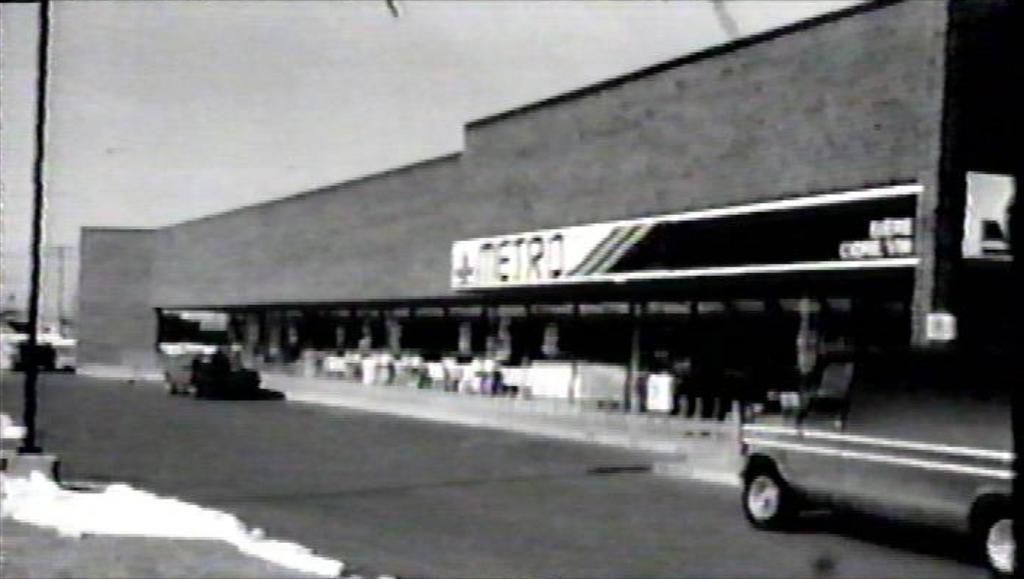What is the color scheme of the image? The image is black and white. How would you describe the clarity of the image? The image is blurred. What is the main subject in the center of the image? There is a building in the center of the image. What can be seen in the foreground of the image? There are cars and a pole in the foreground of the image. Where is the pole located in relation to the road? The pole is on the road. How many snakes are slithering around the pole in the image? There are no snakes present in the image; it features a building, cars, and a pole on the road. What type of shop can be seen near the building in the image? There is no shop visible in the image; it only shows a building, cars, and a pole on the road. 